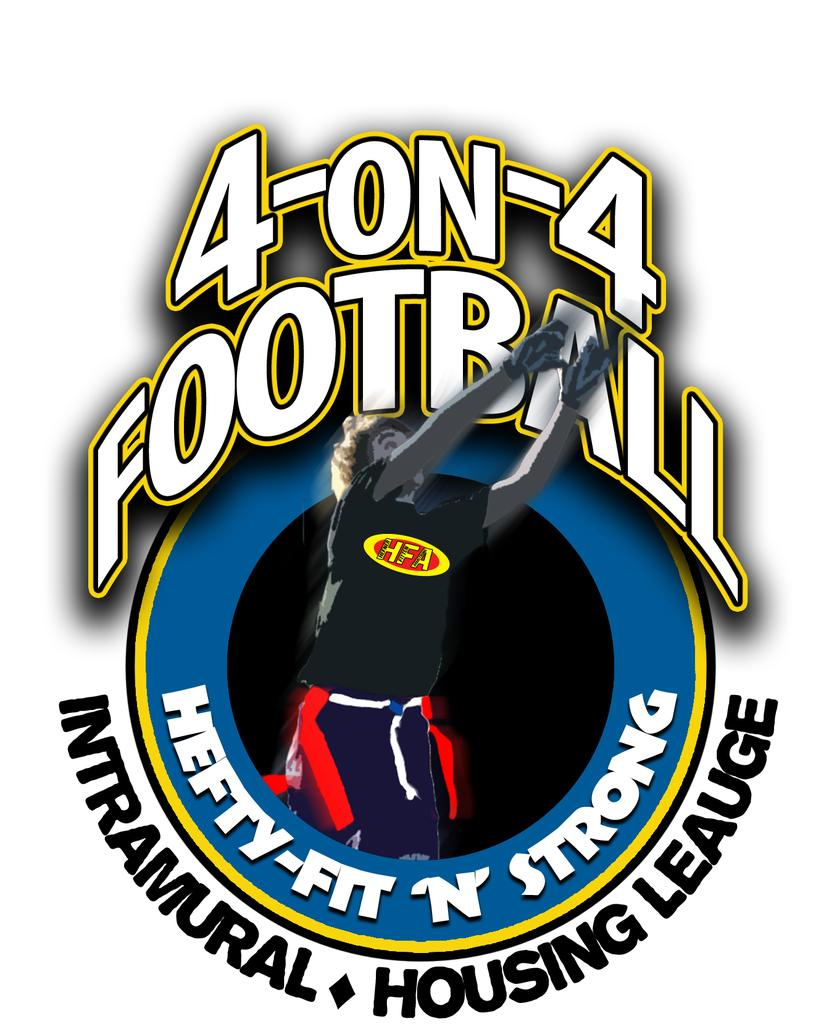<image>
Write a terse but informative summary of the picture. Four on Four football logo for the hefty, fit, and strong. 